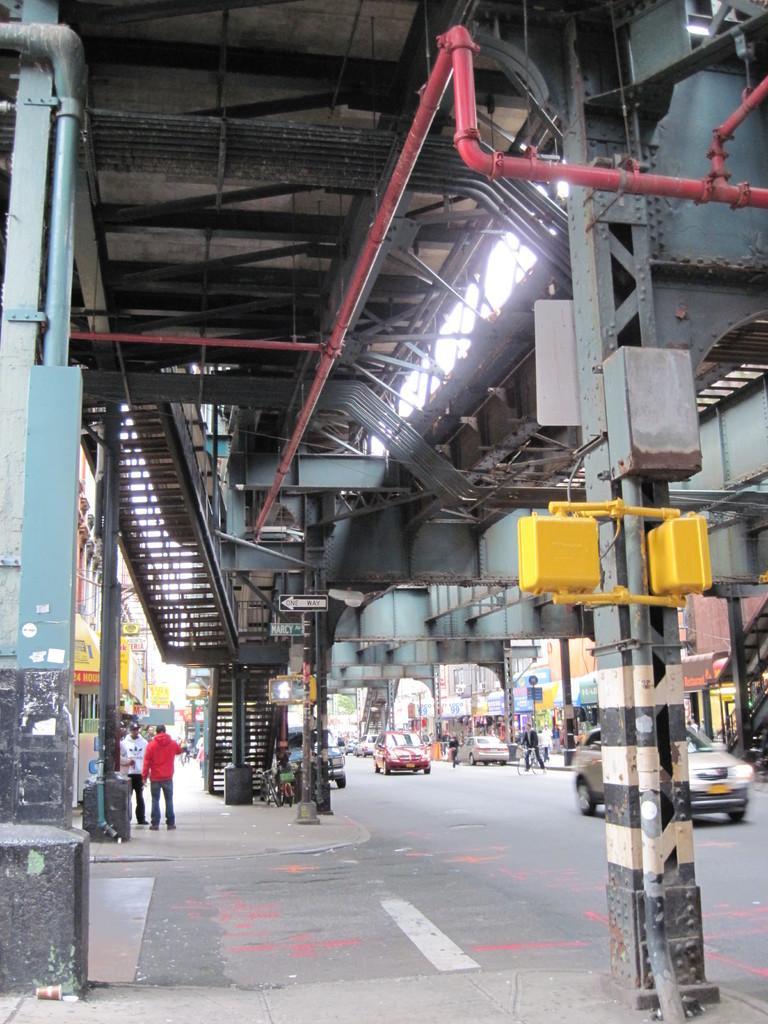In one or two sentences, can you explain what this image depicts? In this image in the front there are poles and in the background there are persons standing and walking, there are cars moving on the road, there are buildings and there is a staircase. On the top there is a pipe which is red in colour. 